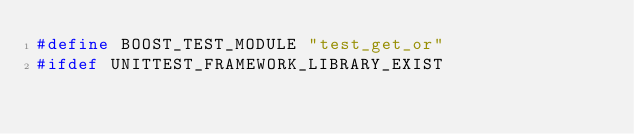<code> <loc_0><loc_0><loc_500><loc_500><_C++_>#define BOOST_TEST_MODULE "test_get_or"
#ifdef UNITTEST_FRAMEWORK_LIBRARY_EXIST</code> 